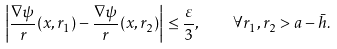Convert formula to latex. <formula><loc_0><loc_0><loc_500><loc_500>\left | \frac { \nabla \psi } { r } ( x , r _ { 1 } ) - \frac { \nabla \psi } { r } ( x , r _ { 2 } ) \right | \leq \frac { \varepsilon } { 3 } , \quad \forall r _ { 1 } , r _ { 2 } > a - \bar { h } .</formula> 